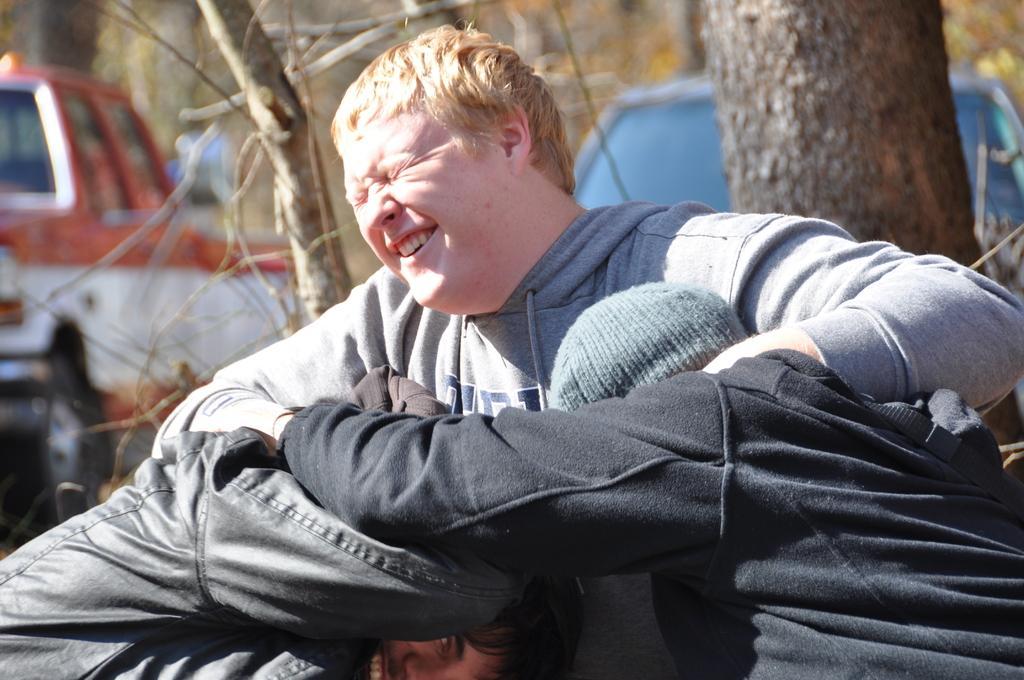Could you give a brief overview of what you see in this image? In this image there are three persons holding each other , in which two persons are smiling , and in the background there are vehicles and trees. 